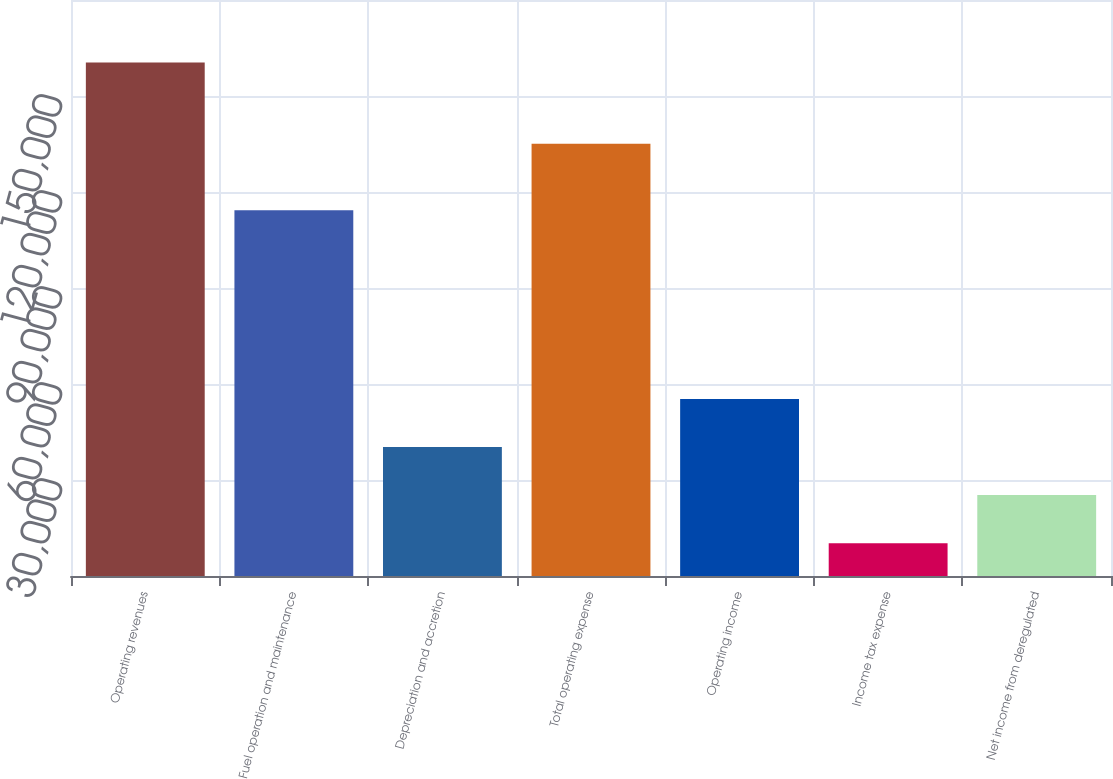Convert chart. <chart><loc_0><loc_0><loc_500><loc_500><bar_chart><fcel>Operating revenues<fcel>Fuel operation and maintenance<fcel>Depreciation and accretion<fcel>Total operating expense<fcel>Operating income<fcel>Income tax expense<fcel>Net income from deregulated<nl><fcel>160478<fcel>114266<fcel>40303.6<fcel>135100<fcel>55325.4<fcel>10260<fcel>25281.8<nl></chart> 